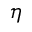<formula> <loc_0><loc_0><loc_500><loc_500>\eta</formula> 